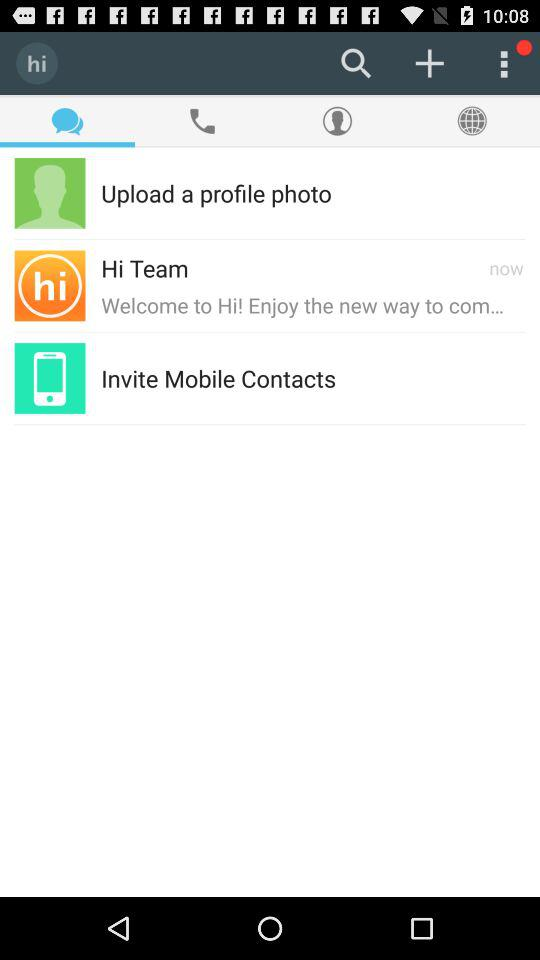When did the "Hi Team" send the message? The "Hi Team" has sent the message now. 